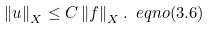<formula> <loc_0><loc_0><loc_500><loc_500>\left \| u \right \| _ { X } \leq C \left \| f \right \| _ { X } . \ e q n o ( 3 . 6 )</formula> 